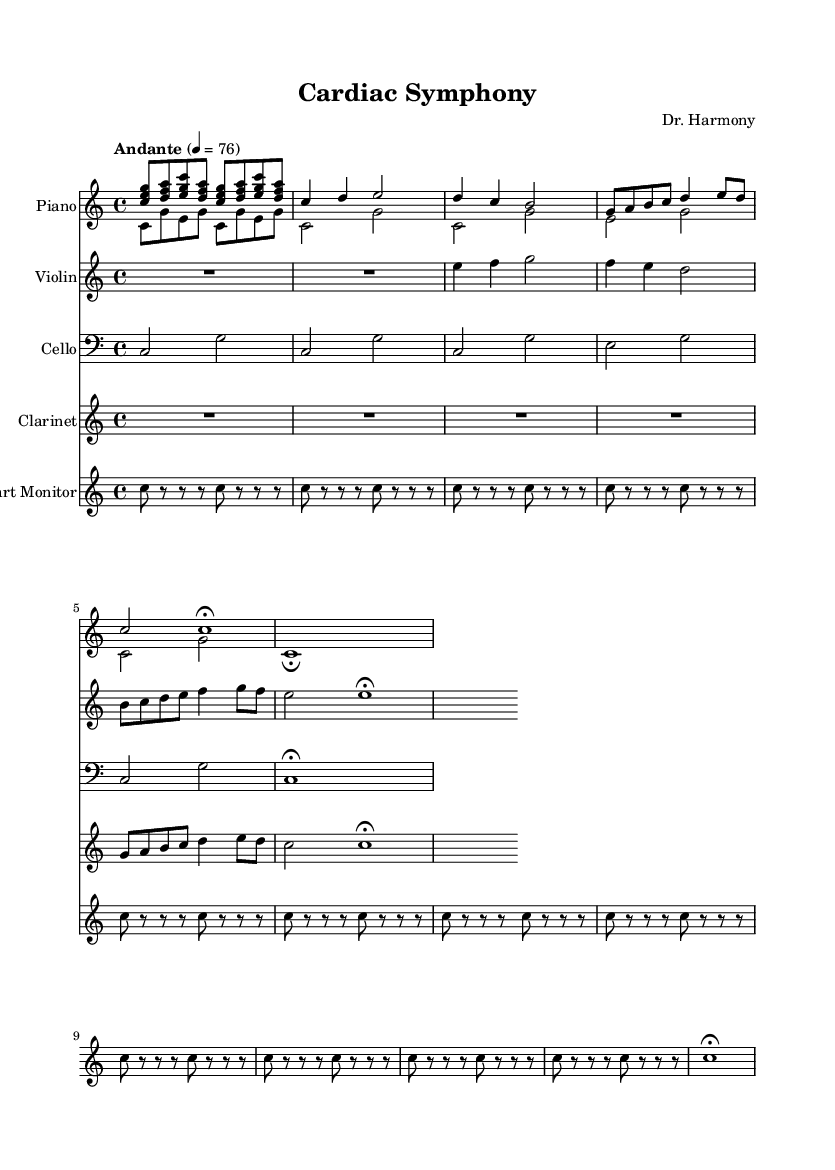What is the key signature of this music? The key signature is indicated at the beginning of the score. It shows no sharps or flats, which corresponds to C major.
Answer: C major What is the time signature of the piece? The time signature is shown at the beginning of the score and indicates four beats per measure, which is represented as 4/4.
Answer: 4/4 What is the tempo marking for this composition? The tempo marking indicates the speed of the piece and is stated in words. Here, it is "Andante", which signifies a moderate pace.
Answer: Andante How many times is the heart monitor sound repeated? The heart monitor sound is represented as a series of rhythmic notes, and upon counting, it repeats eight times in the score before a fermata is noted.
Answer: Eight What instrument is featured as "Heart Monitor" in the score? The "Heart Monitor" part specifically utilizes repeated rhythms that emulate a medical device sound. This confirms it is a unique part in the composition.
Answer: Heart Monitor What type of music is this composition classified as? The unique blend of medical sounds and the overall structure aligns with contemporary classical music, indicating its classification.
Answer: Contemporary classical 